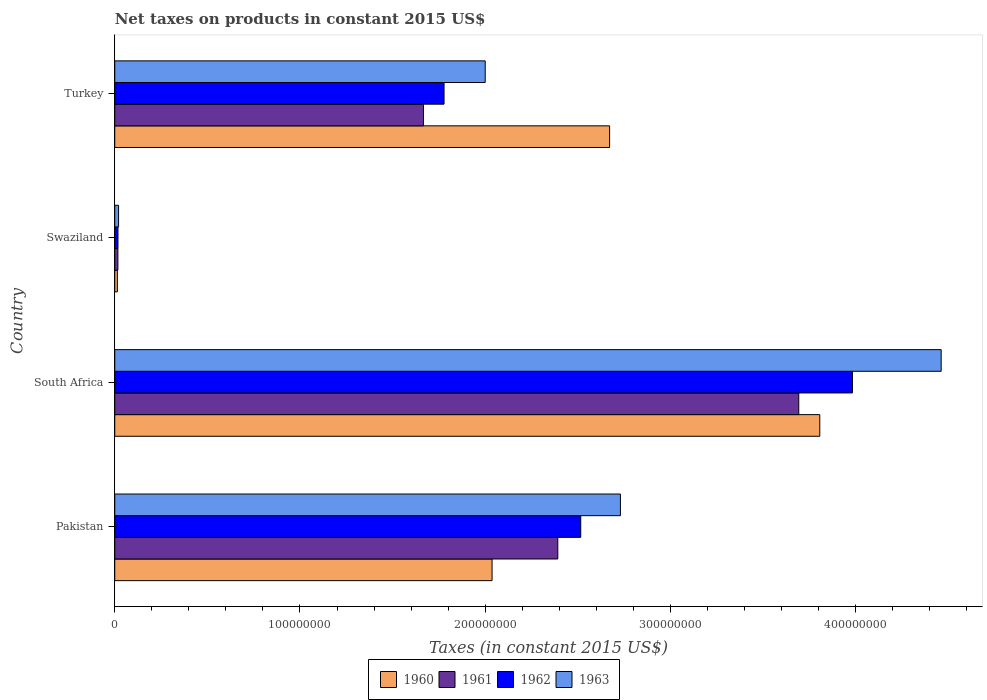Are the number of bars on each tick of the Y-axis equal?
Give a very brief answer. Yes. What is the label of the 2nd group of bars from the top?
Ensure brevity in your answer.  Swaziland. In how many cases, is the number of bars for a given country not equal to the number of legend labels?
Make the answer very short. 0. What is the net taxes on products in 1962 in Turkey?
Ensure brevity in your answer.  1.78e+08. Across all countries, what is the maximum net taxes on products in 1962?
Your response must be concise. 3.98e+08. Across all countries, what is the minimum net taxes on products in 1963?
Make the answer very short. 2.06e+06. In which country was the net taxes on products in 1961 maximum?
Provide a succinct answer. South Africa. In which country was the net taxes on products in 1963 minimum?
Keep it short and to the point. Swaziland. What is the total net taxes on products in 1963 in the graph?
Provide a short and direct response. 9.21e+08. What is the difference between the net taxes on products in 1960 in Pakistan and that in Turkey?
Offer a very short reply. -6.35e+07. What is the difference between the net taxes on products in 1962 in South Africa and the net taxes on products in 1963 in Pakistan?
Provide a short and direct response. 1.25e+08. What is the average net taxes on products in 1963 per country?
Your response must be concise. 2.30e+08. What is the difference between the net taxes on products in 1960 and net taxes on products in 1962 in Turkey?
Make the answer very short. 8.94e+07. What is the ratio of the net taxes on products in 1963 in Pakistan to that in South Africa?
Your answer should be very brief. 0.61. Is the net taxes on products in 1962 in Pakistan less than that in Swaziland?
Make the answer very short. No. Is the difference between the net taxes on products in 1960 in Pakistan and Turkey greater than the difference between the net taxes on products in 1962 in Pakistan and Turkey?
Offer a terse response. No. What is the difference between the highest and the second highest net taxes on products in 1960?
Offer a very short reply. 1.13e+08. What is the difference between the highest and the lowest net taxes on products in 1963?
Your response must be concise. 4.44e+08. In how many countries, is the net taxes on products in 1962 greater than the average net taxes on products in 1962 taken over all countries?
Offer a terse response. 2. Is the sum of the net taxes on products in 1961 in South Africa and Turkey greater than the maximum net taxes on products in 1962 across all countries?
Provide a succinct answer. Yes. Is it the case that in every country, the sum of the net taxes on products in 1963 and net taxes on products in 1961 is greater than the net taxes on products in 1962?
Make the answer very short. Yes. How many bars are there?
Your response must be concise. 16. How many countries are there in the graph?
Provide a succinct answer. 4. What is the difference between two consecutive major ticks on the X-axis?
Make the answer very short. 1.00e+08. Are the values on the major ticks of X-axis written in scientific E-notation?
Provide a short and direct response. No. Does the graph contain any zero values?
Provide a short and direct response. No. Does the graph contain grids?
Offer a terse response. No. How many legend labels are there?
Ensure brevity in your answer.  4. How are the legend labels stacked?
Your answer should be very brief. Horizontal. What is the title of the graph?
Make the answer very short. Net taxes on products in constant 2015 US$. What is the label or title of the X-axis?
Your answer should be compact. Taxes (in constant 2015 US$). What is the Taxes (in constant 2015 US$) of 1960 in Pakistan?
Offer a very short reply. 2.04e+08. What is the Taxes (in constant 2015 US$) in 1961 in Pakistan?
Offer a terse response. 2.39e+08. What is the Taxes (in constant 2015 US$) in 1962 in Pakistan?
Offer a terse response. 2.52e+08. What is the Taxes (in constant 2015 US$) in 1963 in Pakistan?
Provide a short and direct response. 2.73e+08. What is the Taxes (in constant 2015 US$) in 1960 in South Africa?
Make the answer very short. 3.81e+08. What is the Taxes (in constant 2015 US$) of 1961 in South Africa?
Provide a short and direct response. 3.69e+08. What is the Taxes (in constant 2015 US$) of 1962 in South Africa?
Ensure brevity in your answer.  3.98e+08. What is the Taxes (in constant 2015 US$) of 1963 in South Africa?
Your answer should be compact. 4.46e+08. What is the Taxes (in constant 2015 US$) in 1960 in Swaziland?
Provide a short and direct response. 1.40e+06. What is the Taxes (in constant 2015 US$) in 1961 in Swaziland?
Give a very brief answer. 1.69e+06. What is the Taxes (in constant 2015 US$) in 1962 in Swaziland?
Your answer should be compact. 1.73e+06. What is the Taxes (in constant 2015 US$) in 1963 in Swaziland?
Keep it short and to the point. 2.06e+06. What is the Taxes (in constant 2015 US$) in 1960 in Turkey?
Your answer should be compact. 2.67e+08. What is the Taxes (in constant 2015 US$) of 1961 in Turkey?
Your response must be concise. 1.67e+08. What is the Taxes (in constant 2015 US$) in 1962 in Turkey?
Give a very brief answer. 1.78e+08. Across all countries, what is the maximum Taxes (in constant 2015 US$) of 1960?
Your answer should be compact. 3.81e+08. Across all countries, what is the maximum Taxes (in constant 2015 US$) of 1961?
Offer a very short reply. 3.69e+08. Across all countries, what is the maximum Taxes (in constant 2015 US$) of 1962?
Offer a very short reply. 3.98e+08. Across all countries, what is the maximum Taxes (in constant 2015 US$) of 1963?
Provide a short and direct response. 4.46e+08. Across all countries, what is the minimum Taxes (in constant 2015 US$) in 1960?
Make the answer very short. 1.40e+06. Across all countries, what is the minimum Taxes (in constant 2015 US$) in 1961?
Offer a very short reply. 1.69e+06. Across all countries, what is the minimum Taxes (in constant 2015 US$) in 1962?
Your response must be concise. 1.73e+06. Across all countries, what is the minimum Taxes (in constant 2015 US$) in 1963?
Your answer should be very brief. 2.06e+06. What is the total Taxes (in constant 2015 US$) in 1960 in the graph?
Give a very brief answer. 8.53e+08. What is the total Taxes (in constant 2015 US$) of 1961 in the graph?
Ensure brevity in your answer.  7.77e+08. What is the total Taxes (in constant 2015 US$) of 1962 in the graph?
Keep it short and to the point. 8.29e+08. What is the total Taxes (in constant 2015 US$) in 1963 in the graph?
Your answer should be compact. 9.21e+08. What is the difference between the Taxes (in constant 2015 US$) of 1960 in Pakistan and that in South Africa?
Make the answer very short. -1.77e+08. What is the difference between the Taxes (in constant 2015 US$) of 1961 in Pakistan and that in South Africa?
Give a very brief answer. -1.30e+08. What is the difference between the Taxes (in constant 2015 US$) in 1962 in Pakistan and that in South Africa?
Provide a succinct answer. -1.47e+08. What is the difference between the Taxes (in constant 2015 US$) of 1963 in Pakistan and that in South Africa?
Offer a terse response. -1.73e+08. What is the difference between the Taxes (in constant 2015 US$) of 1960 in Pakistan and that in Swaziland?
Your answer should be very brief. 2.02e+08. What is the difference between the Taxes (in constant 2015 US$) in 1961 in Pakistan and that in Swaziland?
Offer a terse response. 2.37e+08. What is the difference between the Taxes (in constant 2015 US$) of 1962 in Pakistan and that in Swaziland?
Keep it short and to the point. 2.50e+08. What is the difference between the Taxes (in constant 2015 US$) of 1963 in Pakistan and that in Swaziland?
Give a very brief answer. 2.71e+08. What is the difference between the Taxes (in constant 2015 US$) in 1960 in Pakistan and that in Turkey?
Make the answer very short. -6.35e+07. What is the difference between the Taxes (in constant 2015 US$) in 1961 in Pakistan and that in Turkey?
Your response must be concise. 7.25e+07. What is the difference between the Taxes (in constant 2015 US$) of 1962 in Pakistan and that in Turkey?
Your answer should be compact. 7.38e+07. What is the difference between the Taxes (in constant 2015 US$) of 1963 in Pakistan and that in Turkey?
Offer a terse response. 7.30e+07. What is the difference between the Taxes (in constant 2015 US$) in 1960 in South Africa and that in Swaziland?
Offer a very short reply. 3.79e+08. What is the difference between the Taxes (in constant 2015 US$) of 1961 in South Africa and that in Swaziland?
Keep it short and to the point. 3.68e+08. What is the difference between the Taxes (in constant 2015 US$) of 1962 in South Africa and that in Swaziland?
Ensure brevity in your answer.  3.97e+08. What is the difference between the Taxes (in constant 2015 US$) in 1963 in South Africa and that in Swaziland?
Offer a very short reply. 4.44e+08. What is the difference between the Taxes (in constant 2015 US$) of 1960 in South Africa and that in Turkey?
Ensure brevity in your answer.  1.13e+08. What is the difference between the Taxes (in constant 2015 US$) of 1961 in South Africa and that in Turkey?
Provide a succinct answer. 2.03e+08. What is the difference between the Taxes (in constant 2015 US$) of 1962 in South Africa and that in Turkey?
Keep it short and to the point. 2.20e+08. What is the difference between the Taxes (in constant 2015 US$) of 1963 in South Africa and that in Turkey?
Offer a terse response. 2.46e+08. What is the difference between the Taxes (in constant 2015 US$) in 1960 in Swaziland and that in Turkey?
Your answer should be very brief. -2.66e+08. What is the difference between the Taxes (in constant 2015 US$) in 1961 in Swaziland and that in Turkey?
Ensure brevity in your answer.  -1.65e+08. What is the difference between the Taxes (in constant 2015 US$) of 1962 in Swaziland and that in Turkey?
Ensure brevity in your answer.  -1.76e+08. What is the difference between the Taxes (in constant 2015 US$) in 1963 in Swaziland and that in Turkey?
Your answer should be compact. -1.98e+08. What is the difference between the Taxes (in constant 2015 US$) in 1960 in Pakistan and the Taxes (in constant 2015 US$) in 1961 in South Africa?
Keep it short and to the point. -1.66e+08. What is the difference between the Taxes (in constant 2015 US$) in 1960 in Pakistan and the Taxes (in constant 2015 US$) in 1962 in South Africa?
Offer a terse response. -1.95e+08. What is the difference between the Taxes (in constant 2015 US$) of 1960 in Pakistan and the Taxes (in constant 2015 US$) of 1963 in South Africa?
Make the answer very short. -2.42e+08. What is the difference between the Taxes (in constant 2015 US$) of 1961 in Pakistan and the Taxes (in constant 2015 US$) of 1962 in South Africa?
Offer a very short reply. -1.59e+08. What is the difference between the Taxes (in constant 2015 US$) in 1961 in Pakistan and the Taxes (in constant 2015 US$) in 1963 in South Africa?
Keep it short and to the point. -2.07e+08. What is the difference between the Taxes (in constant 2015 US$) in 1962 in Pakistan and the Taxes (in constant 2015 US$) in 1963 in South Africa?
Keep it short and to the point. -1.95e+08. What is the difference between the Taxes (in constant 2015 US$) of 1960 in Pakistan and the Taxes (in constant 2015 US$) of 1961 in Swaziland?
Your answer should be compact. 2.02e+08. What is the difference between the Taxes (in constant 2015 US$) of 1960 in Pakistan and the Taxes (in constant 2015 US$) of 1962 in Swaziland?
Make the answer very short. 2.02e+08. What is the difference between the Taxes (in constant 2015 US$) in 1960 in Pakistan and the Taxes (in constant 2015 US$) in 1963 in Swaziland?
Provide a succinct answer. 2.02e+08. What is the difference between the Taxes (in constant 2015 US$) of 1961 in Pakistan and the Taxes (in constant 2015 US$) of 1962 in Swaziland?
Your response must be concise. 2.37e+08. What is the difference between the Taxes (in constant 2015 US$) of 1961 in Pakistan and the Taxes (in constant 2015 US$) of 1963 in Swaziland?
Your response must be concise. 2.37e+08. What is the difference between the Taxes (in constant 2015 US$) of 1962 in Pakistan and the Taxes (in constant 2015 US$) of 1963 in Swaziland?
Offer a terse response. 2.50e+08. What is the difference between the Taxes (in constant 2015 US$) in 1960 in Pakistan and the Taxes (in constant 2015 US$) in 1961 in Turkey?
Your answer should be compact. 3.70e+07. What is the difference between the Taxes (in constant 2015 US$) of 1960 in Pakistan and the Taxes (in constant 2015 US$) of 1962 in Turkey?
Offer a terse response. 2.59e+07. What is the difference between the Taxes (in constant 2015 US$) of 1960 in Pakistan and the Taxes (in constant 2015 US$) of 1963 in Turkey?
Ensure brevity in your answer.  3.70e+06. What is the difference between the Taxes (in constant 2015 US$) in 1961 in Pakistan and the Taxes (in constant 2015 US$) in 1962 in Turkey?
Provide a succinct answer. 6.14e+07. What is the difference between the Taxes (in constant 2015 US$) in 1961 in Pakistan and the Taxes (in constant 2015 US$) in 1963 in Turkey?
Provide a succinct answer. 3.92e+07. What is the difference between the Taxes (in constant 2015 US$) in 1962 in Pakistan and the Taxes (in constant 2015 US$) in 1963 in Turkey?
Offer a terse response. 5.16e+07. What is the difference between the Taxes (in constant 2015 US$) in 1960 in South Africa and the Taxes (in constant 2015 US$) in 1961 in Swaziland?
Your answer should be compact. 3.79e+08. What is the difference between the Taxes (in constant 2015 US$) in 1960 in South Africa and the Taxes (in constant 2015 US$) in 1962 in Swaziland?
Ensure brevity in your answer.  3.79e+08. What is the difference between the Taxes (in constant 2015 US$) of 1960 in South Africa and the Taxes (in constant 2015 US$) of 1963 in Swaziland?
Your response must be concise. 3.79e+08. What is the difference between the Taxes (in constant 2015 US$) of 1961 in South Africa and the Taxes (in constant 2015 US$) of 1962 in Swaziland?
Give a very brief answer. 3.68e+08. What is the difference between the Taxes (in constant 2015 US$) of 1961 in South Africa and the Taxes (in constant 2015 US$) of 1963 in Swaziland?
Ensure brevity in your answer.  3.67e+08. What is the difference between the Taxes (in constant 2015 US$) in 1962 in South Africa and the Taxes (in constant 2015 US$) in 1963 in Swaziland?
Your answer should be very brief. 3.96e+08. What is the difference between the Taxes (in constant 2015 US$) in 1960 in South Africa and the Taxes (in constant 2015 US$) in 1961 in Turkey?
Your answer should be compact. 2.14e+08. What is the difference between the Taxes (in constant 2015 US$) of 1960 in South Africa and the Taxes (in constant 2015 US$) of 1962 in Turkey?
Offer a very short reply. 2.03e+08. What is the difference between the Taxes (in constant 2015 US$) in 1960 in South Africa and the Taxes (in constant 2015 US$) in 1963 in Turkey?
Provide a short and direct response. 1.81e+08. What is the difference between the Taxes (in constant 2015 US$) of 1961 in South Africa and the Taxes (in constant 2015 US$) of 1962 in Turkey?
Offer a very short reply. 1.91e+08. What is the difference between the Taxes (in constant 2015 US$) of 1961 in South Africa and the Taxes (in constant 2015 US$) of 1963 in Turkey?
Ensure brevity in your answer.  1.69e+08. What is the difference between the Taxes (in constant 2015 US$) of 1962 in South Africa and the Taxes (in constant 2015 US$) of 1963 in Turkey?
Provide a succinct answer. 1.98e+08. What is the difference between the Taxes (in constant 2015 US$) in 1960 in Swaziland and the Taxes (in constant 2015 US$) in 1961 in Turkey?
Offer a terse response. -1.65e+08. What is the difference between the Taxes (in constant 2015 US$) of 1960 in Swaziland and the Taxes (in constant 2015 US$) of 1962 in Turkey?
Make the answer very short. -1.76e+08. What is the difference between the Taxes (in constant 2015 US$) of 1960 in Swaziland and the Taxes (in constant 2015 US$) of 1963 in Turkey?
Make the answer very short. -1.99e+08. What is the difference between the Taxes (in constant 2015 US$) of 1961 in Swaziland and the Taxes (in constant 2015 US$) of 1962 in Turkey?
Your response must be concise. -1.76e+08. What is the difference between the Taxes (in constant 2015 US$) of 1961 in Swaziland and the Taxes (in constant 2015 US$) of 1963 in Turkey?
Give a very brief answer. -1.98e+08. What is the difference between the Taxes (in constant 2015 US$) in 1962 in Swaziland and the Taxes (in constant 2015 US$) in 1963 in Turkey?
Offer a terse response. -1.98e+08. What is the average Taxes (in constant 2015 US$) of 1960 per country?
Offer a terse response. 2.13e+08. What is the average Taxes (in constant 2015 US$) of 1961 per country?
Your answer should be very brief. 1.94e+08. What is the average Taxes (in constant 2015 US$) in 1962 per country?
Offer a terse response. 2.07e+08. What is the average Taxes (in constant 2015 US$) of 1963 per country?
Offer a very short reply. 2.30e+08. What is the difference between the Taxes (in constant 2015 US$) in 1960 and Taxes (in constant 2015 US$) in 1961 in Pakistan?
Your response must be concise. -3.55e+07. What is the difference between the Taxes (in constant 2015 US$) in 1960 and Taxes (in constant 2015 US$) in 1962 in Pakistan?
Your answer should be compact. -4.79e+07. What is the difference between the Taxes (in constant 2015 US$) in 1960 and Taxes (in constant 2015 US$) in 1963 in Pakistan?
Your answer should be compact. -6.93e+07. What is the difference between the Taxes (in constant 2015 US$) of 1961 and Taxes (in constant 2015 US$) of 1962 in Pakistan?
Your answer should be compact. -1.24e+07. What is the difference between the Taxes (in constant 2015 US$) of 1961 and Taxes (in constant 2015 US$) of 1963 in Pakistan?
Your response must be concise. -3.38e+07. What is the difference between the Taxes (in constant 2015 US$) in 1962 and Taxes (in constant 2015 US$) in 1963 in Pakistan?
Keep it short and to the point. -2.14e+07. What is the difference between the Taxes (in constant 2015 US$) of 1960 and Taxes (in constant 2015 US$) of 1961 in South Africa?
Offer a terse response. 1.13e+07. What is the difference between the Taxes (in constant 2015 US$) in 1960 and Taxes (in constant 2015 US$) in 1962 in South Africa?
Provide a succinct answer. -1.76e+07. What is the difference between the Taxes (in constant 2015 US$) of 1960 and Taxes (in constant 2015 US$) of 1963 in South Africa?
Make the answer very short. -6.55e+07. What is the difference between the Taxes (in constant 2015 US$) of 1961 and Taxes (in constant 2015 US$) of 1962 in South Africa?
Provide a succinct answer. -2.90e+07. What is the difference between the Taxes (in constant 2015 US$) of 1961 and Taxes (in constant 2015 US$) of 1963 in South Africa?
Keep it short and to the point. -7.69e+07. What is the difference between the Taxes (in constant 2015 US$) of 1962 and Taxes (in constant 2015 US$) of 1963 in South Africa?
Your response must be concise. -4.79e+07. What is the difference between the Taxes (in constant 2015 US$) of 1960 and Taxes (in constant 2015 US$) of 1961 in Swaziland?
Offer a terse response. -2.89e+05. What is the difference between the Taxes (in constant 2015 US$) of 1960 and Taxes (in constant 2015 US$) of 1962 in Swaziland?
Provide a succinct answer. -3.30e+05. What is the difference between the Taxes (in constant 2015 US$) of 1960 and Taxes (in constant 2015 US$) of 1963 in Swaziland?
Your answer should be very brief. -6.61e+05. What is the difference between the Taxes (in constant 2015 US$) of 1961 and Taxes (in constant 2015 US$) of 1962 in Swaziland?
Offer a terse response. -4.13e+04. What is the difference between the Taxes (in constant 2015 US$) in 1961 and Taxes (in constant 2015 US$) in 1963 in Swaziland?
Your answer should be compact. -3.72e+05. What is the difference between the Taxes (in constant 2015 US$) in 1962 and Taxes (in constant 2015 US$) in 1963 in Swaziland?
Keep it short and to the point. -3.30e+05. What is the difference between the Taxes (in constant 2015 US$) in 1960 and Taxes (in constant 2015 US$) in 1961 in Turkey?
Your response must be concise. 1.00e+08. What is the difference between the Taxes (in constant 2015 US$) of 1960 and Taxes (in constant 2015 US$) of 1962 in Turkey?
Your answer should be compact. 8.94e+07. What is the difference between the Taxes (in constant 2015 US$) of 1960 and Taxes (in constant 2015 US$) of 1963 in Turkey?
Your response must be concise. 6.72e+07. What is the difference between the Taxes (in constant 2015 US$) in 1961 and Taxes (in constant 2015 US$) in 1962 in Turkey?
Your answer should be very brief. -1.11e+07. What is the difference between the Taxes (in constant 2015 US$) in 1961 and Taxes (in constant 2015 US$) in 1963 in Turkey?
Keep it short and to the point. -3.33e+07. What is the difference between the Taxes (in constant 2015 US$) of 1962 and Taxes (in constant 2015 US$) of 1963 in Turkey?
Ensure brevity in your answer.  -2.22e+07. What is the ratio of the Taxes (in constant 2015 US$) of 1960 in Pakistan to that in South Africa?
Make the answer very short. 0.54. What is the ratio of the Taxes (in constant 2015 US$) in 1961 in Pakistan to that in South Africa?
Offer a terse response. 0.65. What is the ratio of the Taxes (in constant 2015 US$) in 1962 in Pakistan to that in South Africa?
Ensure brevity in your answer.  0.63. What is the ratio of the Taxes (in constant 2015 US$) in 1963 in Pakistan to that in South Africa?
Ensure brevity in your answer.  0.61. What is the ratio of the Taxes (in constant 2015 US$) in 1960 in Pakistan to that in Swaziland?
Give a very brief answer. 145.12. What is the ratio of the Taxes (in constant 2015 US$) in 1961 in Pakistan to that in Swaziland?
Offer a very short reply. 141.31. What is the ratio of the Taxes (in constant 2015 US$) of 1962 in Pakistan to that in Swaziland?
Offer a terse response. 145.09. What is the ratio of the Taxes (in constant 2015 US$) in 1963 in Pakistan to that in Swaziland?
Provide a short and direct response. 132.25. What is the ratio of the Taxes (in constant 2015 US$) in 1960 in Pakistan to that in Turkey?
Offer a very short reply. 0.76. What is the ratio of the Taxes (in constant 2015 US$) of 1961 in Pakistan to that in Turkey?
Make the answer very short. 1.44. What is the ratio of the Taxes (in constant 2015 US$) of 1962 in Pakistan to that in Turkey?
Your answer should be very brief. 1.42. What is the ratio of the Taxes (in constant 2015 US$) in 1963 in Pakistan to that in Turkey?
Ensure brevity in your answer.  1.36. What is the ratio of the Taxes (in constant 2015 US$) of 1960 in South Africa to that in Swaziland?
Offer a very short reply. 271.17. What is the ratio of the Taxes (in constant 2015 US$) of 1961 in South Africa to that in Swaziland?
Give a very brief answer. 218.17. What is the ratio of the Taxes (in constant 2015 US$) in 1962 in South Africa to that in Swaziland?
Ensure brevity in your answer.  229.69. What is the ratio of the Taxes (in constant 2015 US$) in 1963 in South Africa to that in Swaziland?
Your answer should be compact. 216.15. What is the ratio of the Taxes (in constant 2015 US$) of 1960 in South Africa to that in Turkey?
Offer a very short reply. 1.42. What is the ratio of the Taxes (in constant 2015 US$) in 1961 in South Africa to that in Turkey?
Offer a very short reply. 2.22. What is the ratio of the Taxes (in constant 2015 US$) in 1962 in South Africa to that in Turkey?
Keep it short and to the point. 2.24. What is the ratio of the Taxes (in constant 2015 US$) of 1963 in South Africa to that in Turkey?
Keep it short and to the point. 2.23. What is the ratio of the Taxes (in constant 2015 US$) in 1960 in Swaziland to that in Turkey?
Make the answer very short. 0.01. What is the ratio of the Taxes (in constant 2015 US$) in 1961 in Swaziland to that in Turkey?
Your answer should be very brief. 0.01. What is the ratio of the Taxes (in constant 2015 US$) of 1962 in Swaziland to that in Turkey?
Ensure brevity in your answer.  0.01. What is the ratio of the Taxes (in constant 2015 US$) of 1963 in Swaziland to that in Turkey?
Give a very brief answer. 0.01. What is the difference between the highest and the second highest Taxes (in constant 2015 US$) in 1960?
Your response must be concise. 1.13e+08. What is the difference between the highest and the second highest Taxes (in constant 2015 US$) of 1961?
Ensure brevity in your answer.  1.30e+08. What is the difference between the highest and the second highest Taxes (in constant 2015 US$) of 1962?
Ensure brevity in your answer.  1.47e+08. What is the difference between the highest and the second highest Taxes (in constant 2015 US$) of 1963?
Offer a terse response. 1.73e+08. What is the difference between the highest and the lowest Taxes (in constant 2015 US$) of 1960?
Offer a very short reply. 3.79e+08. What is the difference between the highest and the lowest Taxes (in constant 2015 US$) of 1961?
Ensure brevity in your answer.  3.68e+08. What is the difference between the highest and the lowest Taxes (in constant 2015 US$) of 1962?
Make the answer very short. 3.97e+08. What is the difference between the highest and the lowest Taxes (in constant 2015 US$) in 1963?
Keep it short and to the point. 4.44e+08. 